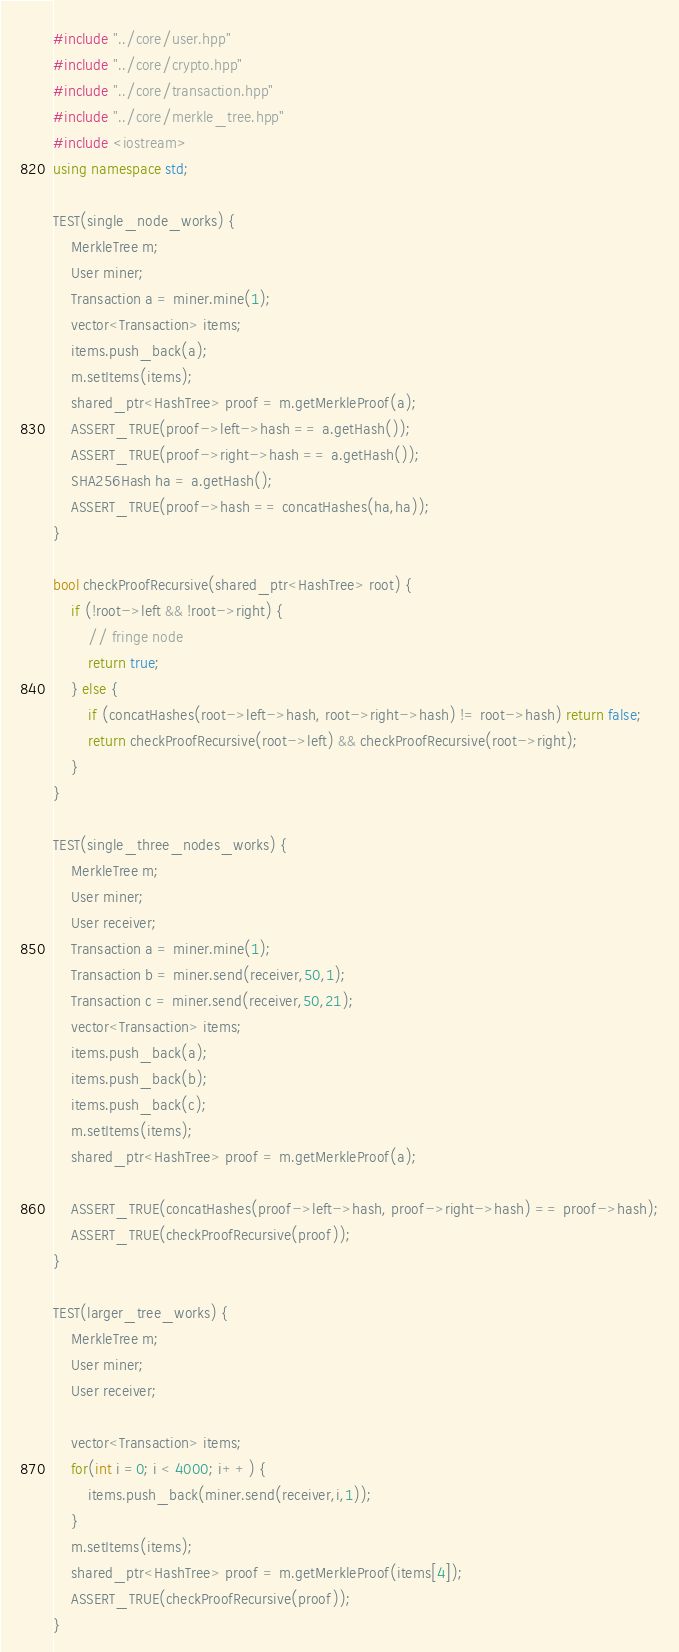Convert code to text. <code><loc_0><loc_0><loc_500><loc_500><_C++_>#include "../core/user.hpp"
#include "../core/crypto.hpp"
#include "../core/transaction.hpp"
#include "../core/merkle_tree.hpp"
#include <iostream>
using namespace std;

TEST(single_node_works) {
    MerkleTree m;
    User miner;
    Transaction a = miner.mine(1);
    vector<Transaction> items;
    items.push_back(a);
    m.setItems(items);
    shared_ptr<HashTree> proof = m.getMerkleProof(a);
    ASSERT_TRUE(proof->left->hash == a.getHash());
    ASSERT_TRUE(proof->right->hash == a.getHash());
    SHA256Hash ha = a.getHash();
    ASSERT_TRUE(proof->hash == concatHashes(ha,ha));
}

bool checkProofRecursive(shared_ptr<HashTree> root) {
    if (!root->left && !root->right) {
        // fringe node
        return true;
    } else {
        if (concatHashes(root->left->hash, root->right->hash) != root->hash) return false;
        return checkProofRecursive(root->left) && checkProofRecursive(root->right);
    }
}

TEST(single_three_nodes_works) {
    MerkleTree m;
    User miner;
    User receiver;
    Transaction a = miner.mine(1);
    Transaction b = miner.send(receiver,50,1);
    Transaction c = miner.send(receiver,50,21);
    vector<Transaction> items;
    items.push_back(a);
    items.push_back(b);
    items.push_back(c);
    m.setItems(items);
    shared_ptr<HashTree> proof = m.getMerkleProof(a);
    
    ASSERT_TRUE(concatHashes(proof->left->hash, proof->right->hash) == proof->hash);
    ASSERT_TRUE(checkProofRecursive(proof));
}

TEST(larger_tree_works) {
    MerkleTree m;
    User miner;
    User receiver;

    vector<Transaction> items;
    for(int i =0; i < 4000; i++) {
        items.push_back(miner.send(receiver,i,1));
    }
    m.setItems(items);
    shared_ptr<HashTree> proof = m.getMerkleProof(items[4]);
    ASSERT_TRUE(checkProofRecursive(proof));
}</code> 